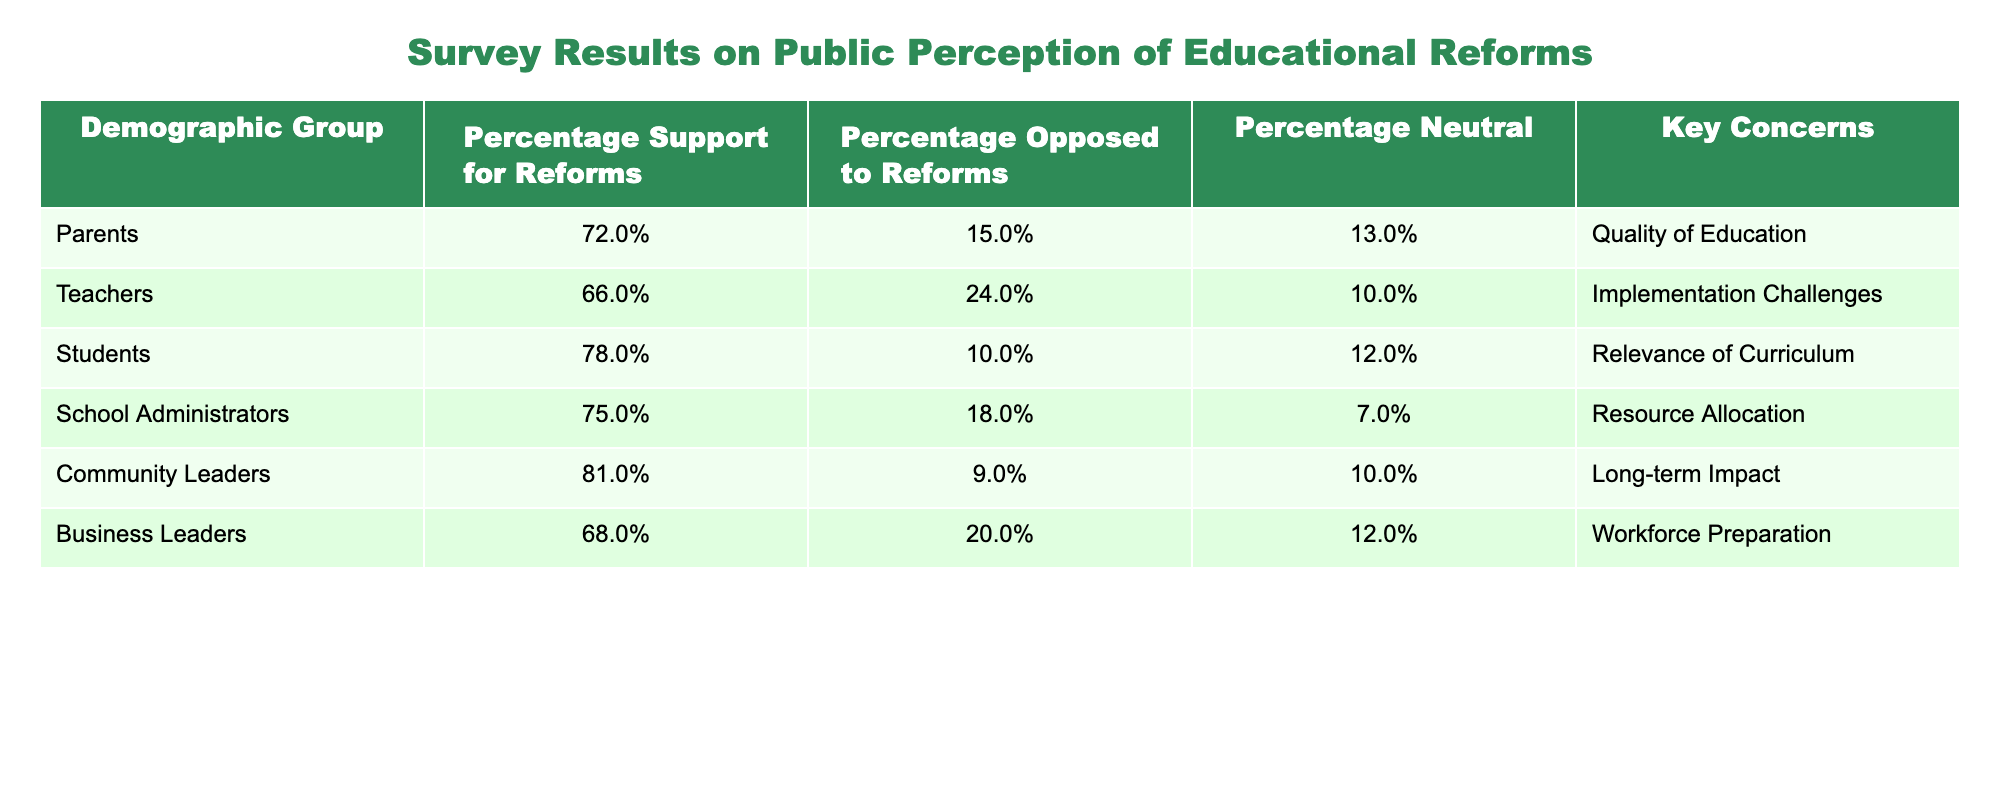What percentage of parents support the reforms? According to the table, the percentage support for reforms by parents is specifically listed under their demographic group. The value is 72%.
Answer: 72% Which demographic group has the highest percentage of neutral responses? By examining the "Percentage Neutral" column for all demographic groups, School Administrators have the highest percentage at 7%.
Answer: 7% What is the difference in support for reforms between students and business leaders? The percentage support for reforms among students is 78%, while for business leaders it is 68%. The difference is calculated as 78% - 68% = 10%.
Answer: 10% Do more community leaders support the reforms compared to teachers? Looking at the "Percentage Support for Reforms," community leaders have 81% support while teachers have 66%. Since 81% is greater than 66%, the answer is yes.
Answer: Yes What is the average percentage of support for reforms among all demographic groups? The average is found by summing the support percentages: (72% + 66% + 78% + 75% + 81% + 68%)/6 = 440%/6 = 73.33%. Thus, the average percentage of support is 73.33%.
Answer: 73.33% Which demographic group has the greatest concerns regarding the relevance of the curriculum? The concerns about relevance are specifically mentioned for students in the "Key Concerns" column. Therefore, students express this concern.
Answer: Students What percentage of school administrators oppose the reforms? The percentage opposed by school administrators is indicated in the "Percentage Opposed to Reforms" column, which is 18%.
Answer: 18% How many more percentage points do community leaders support the reforms compared to parents? Community leaders have 81% support while parents have 72%. The difference is calculated as 81% - 72% = 9%.
Answer: 9% 